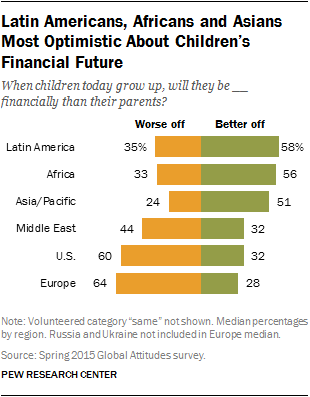Draw attention to some important aspects in this diagram. According to the data, the percentage of people who are better off than those who are worse off in Africa is 1.69 times higher. The question in the chart is whether the children will be worse or better off than their parents when they grow up. 